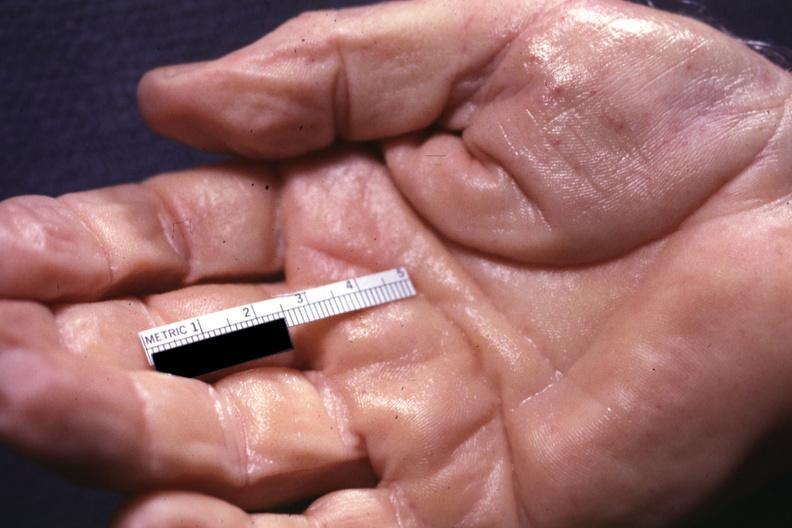re liver with tuberculoid granuloma in glissons present?
Answer the question using a single word or phrase. Yes 